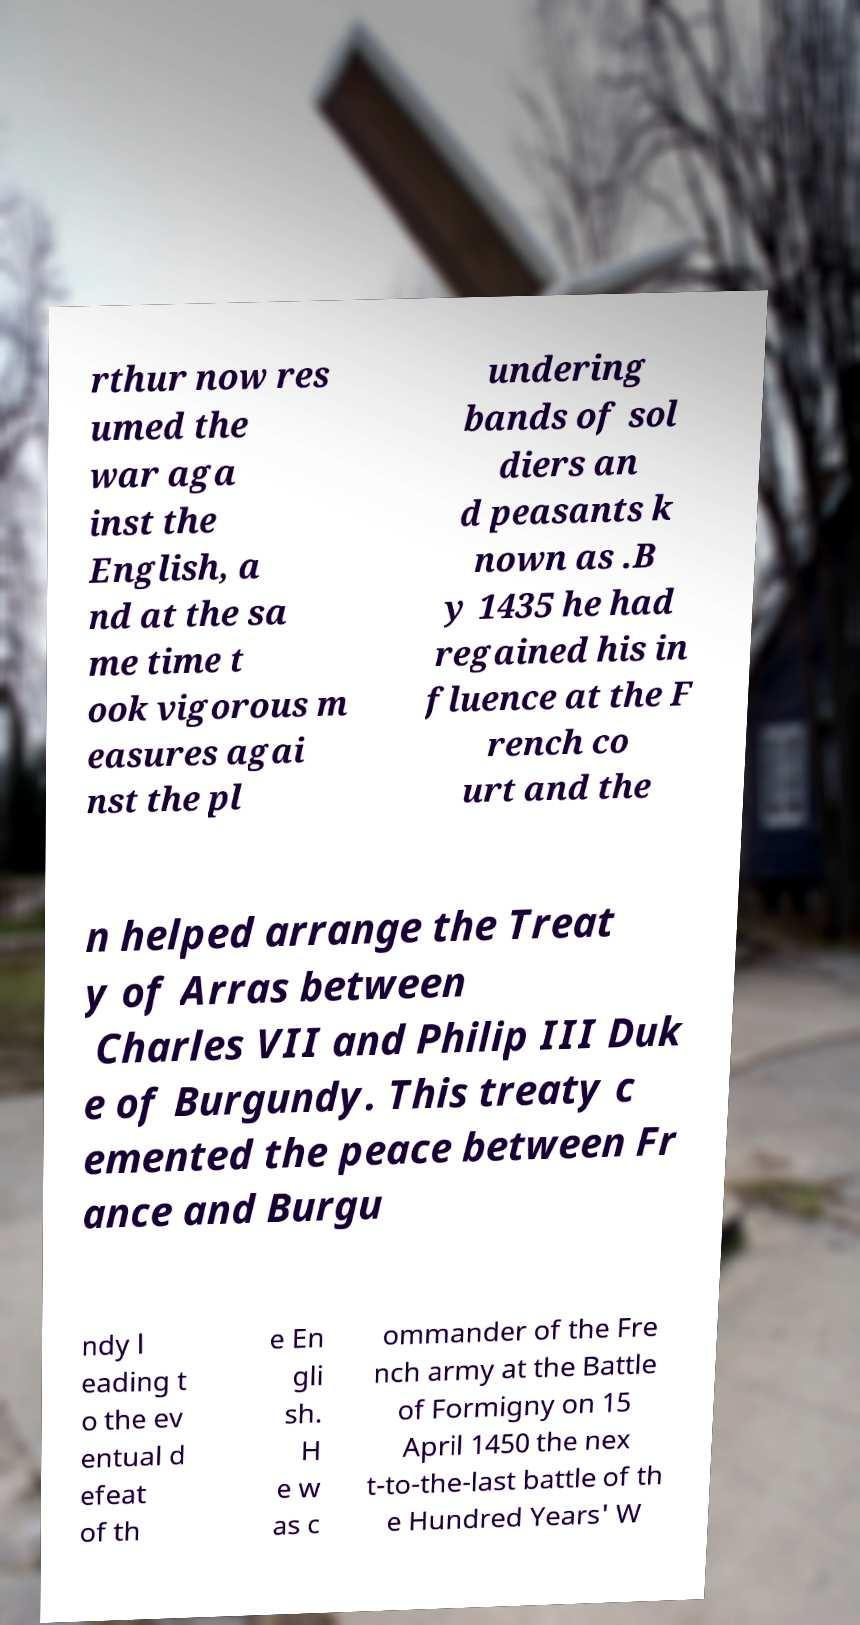What messages or text are displayed in this image? I need them in a readable, typed format. rthur now res umed the war aga inst the English, a nd at the sa me time t ook vigorous m easures agai nst the pl undering bands of sol diers an d peasants k nown as .B y 1435 he had regained his in fluence at the F rench co urt and the n helped arrange the Treat y of Arras between Charles VII and Philip III Duk e of Burgundy. This treaty c emented the peace between Fr ance and Burgu ndy l eading t o the ev entual d efeat of th e En gli sh. H e w as c ommander of the Fre nch army at the Battle of Formigny on 15 April 1450 the nex t-to-the-last battle of th e Hundred Years' W 